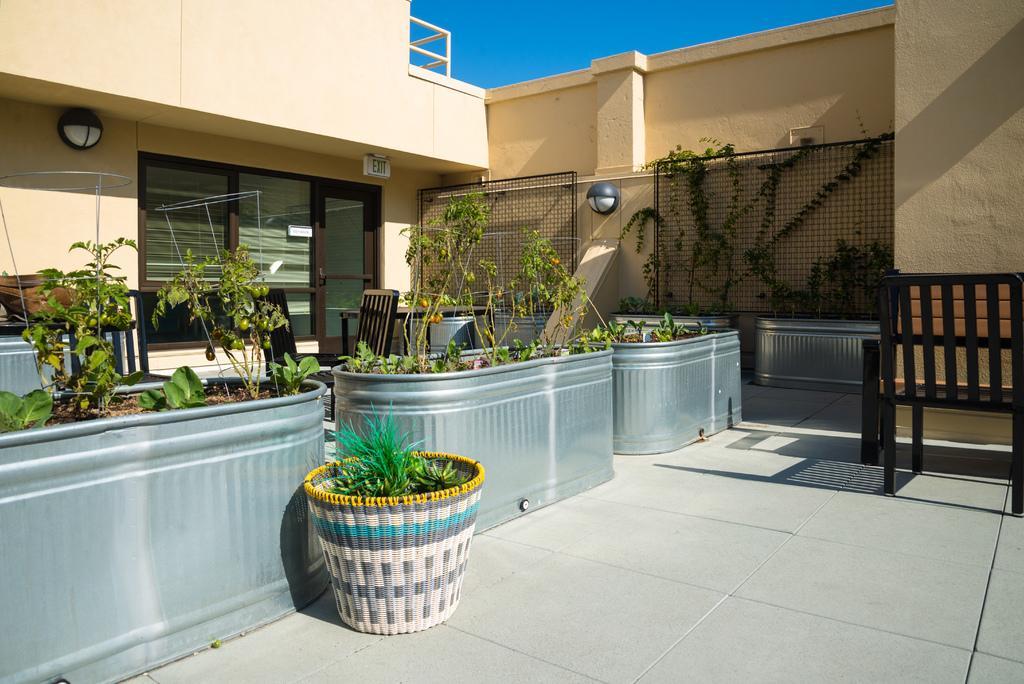In one or two sentences, can you explain what this image depicts? In this image, there are several plants planted in the pots in front of the house. In the middle side of the image, there are creepers which are on the iron net. In the right side of the image middle, I can see a chair. In the middle top of the image, sky is visible which is blue in color. The picture is taken from outside during sunny day. And a window is visible which is made up of glass. 